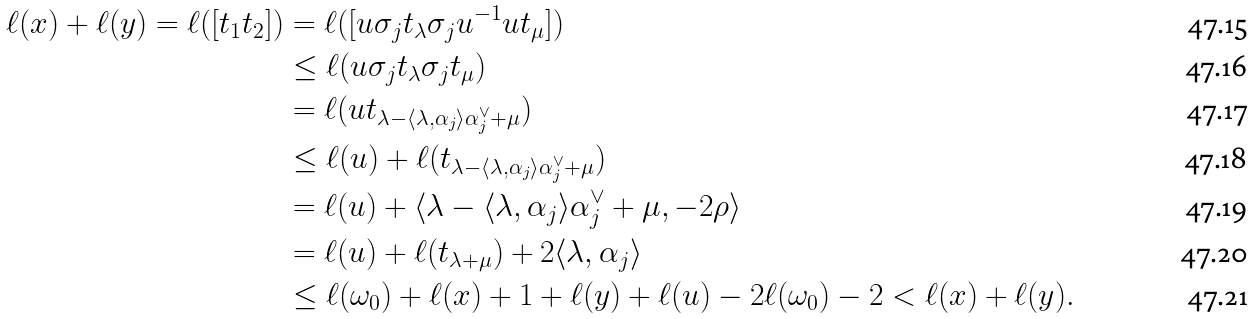<formula> <loc_0><loc_0><loc_500><loc_500>\ell ( x ) + \ell ( y ) = \ell ( [ t _ { 1 } t _ { 2 } ] ) & = \ell ( [ u \sigma _ { j } t _ { \lambda } \sigma _ { j } u ^ { - 1 } u t _ { \mu } ] ) \\ & \leq \ell ( u \sigma _ { j } t _ { \lambda } \sigma _ { j } t _ { \mu } ) \\ & = \ell ( u t _ { \lambda - \langle \lambda , \alpha _ { j } \rangle \alpha _ { j } ^ { \vee } + \mu } ) \\ & \leq \ell ( u ) + \ell ( t _ { \lambda - \langle \lambda , \alpha _ { j } \rangle \alpha _ { j } ^ { \vee } + \mu } ) \\ & = \ell ( u ) + \langle \lambda - \langle \lambda , \alpha _ { j } \rangle \alpha _ { j } ^ { \vee } + \mu , - 2 \rho \rangle \\ & = \ell ( u ) + \ell ( t _ { \lambda + \mu } ) + 2 \langle \lambda , \alpha _ { j } \rangle \\ & \leq \ell ( \omega _ { 0 } ) + \ell ( x ) + 1 + \ell ( y ) + \ell ( u ) - 2 \ell ( \omega _ { 0 } ) - 2 < \ell ( x ) + \ell ( y ) .</formula> 